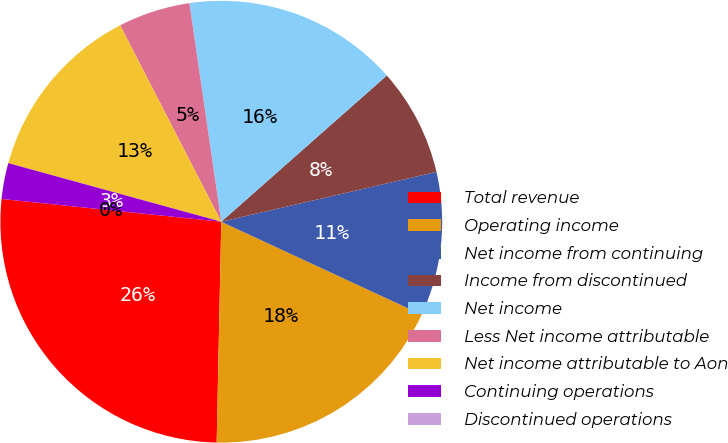<chart> <loc_0><loc_0><loc_500><loc_500><pie_chart><fcel>Total revenue<fcel>Operating income<fcel>Net income from continuing<fcel>Income from discontinued<fcel>Net income<fcel>Less Net income attributable<fcel>Net income attributable to Aon<fcel>Continuing operations<fcel>Discontinued operations<nl><fcel>26.31%<fcel>18.42%<fcel>10.53%<fcel>7.89%<fcel>15.79%<fcel>5.26%<fcel>13.16%<fcel>2.63%<fcel>0.0%<nl></chart> 